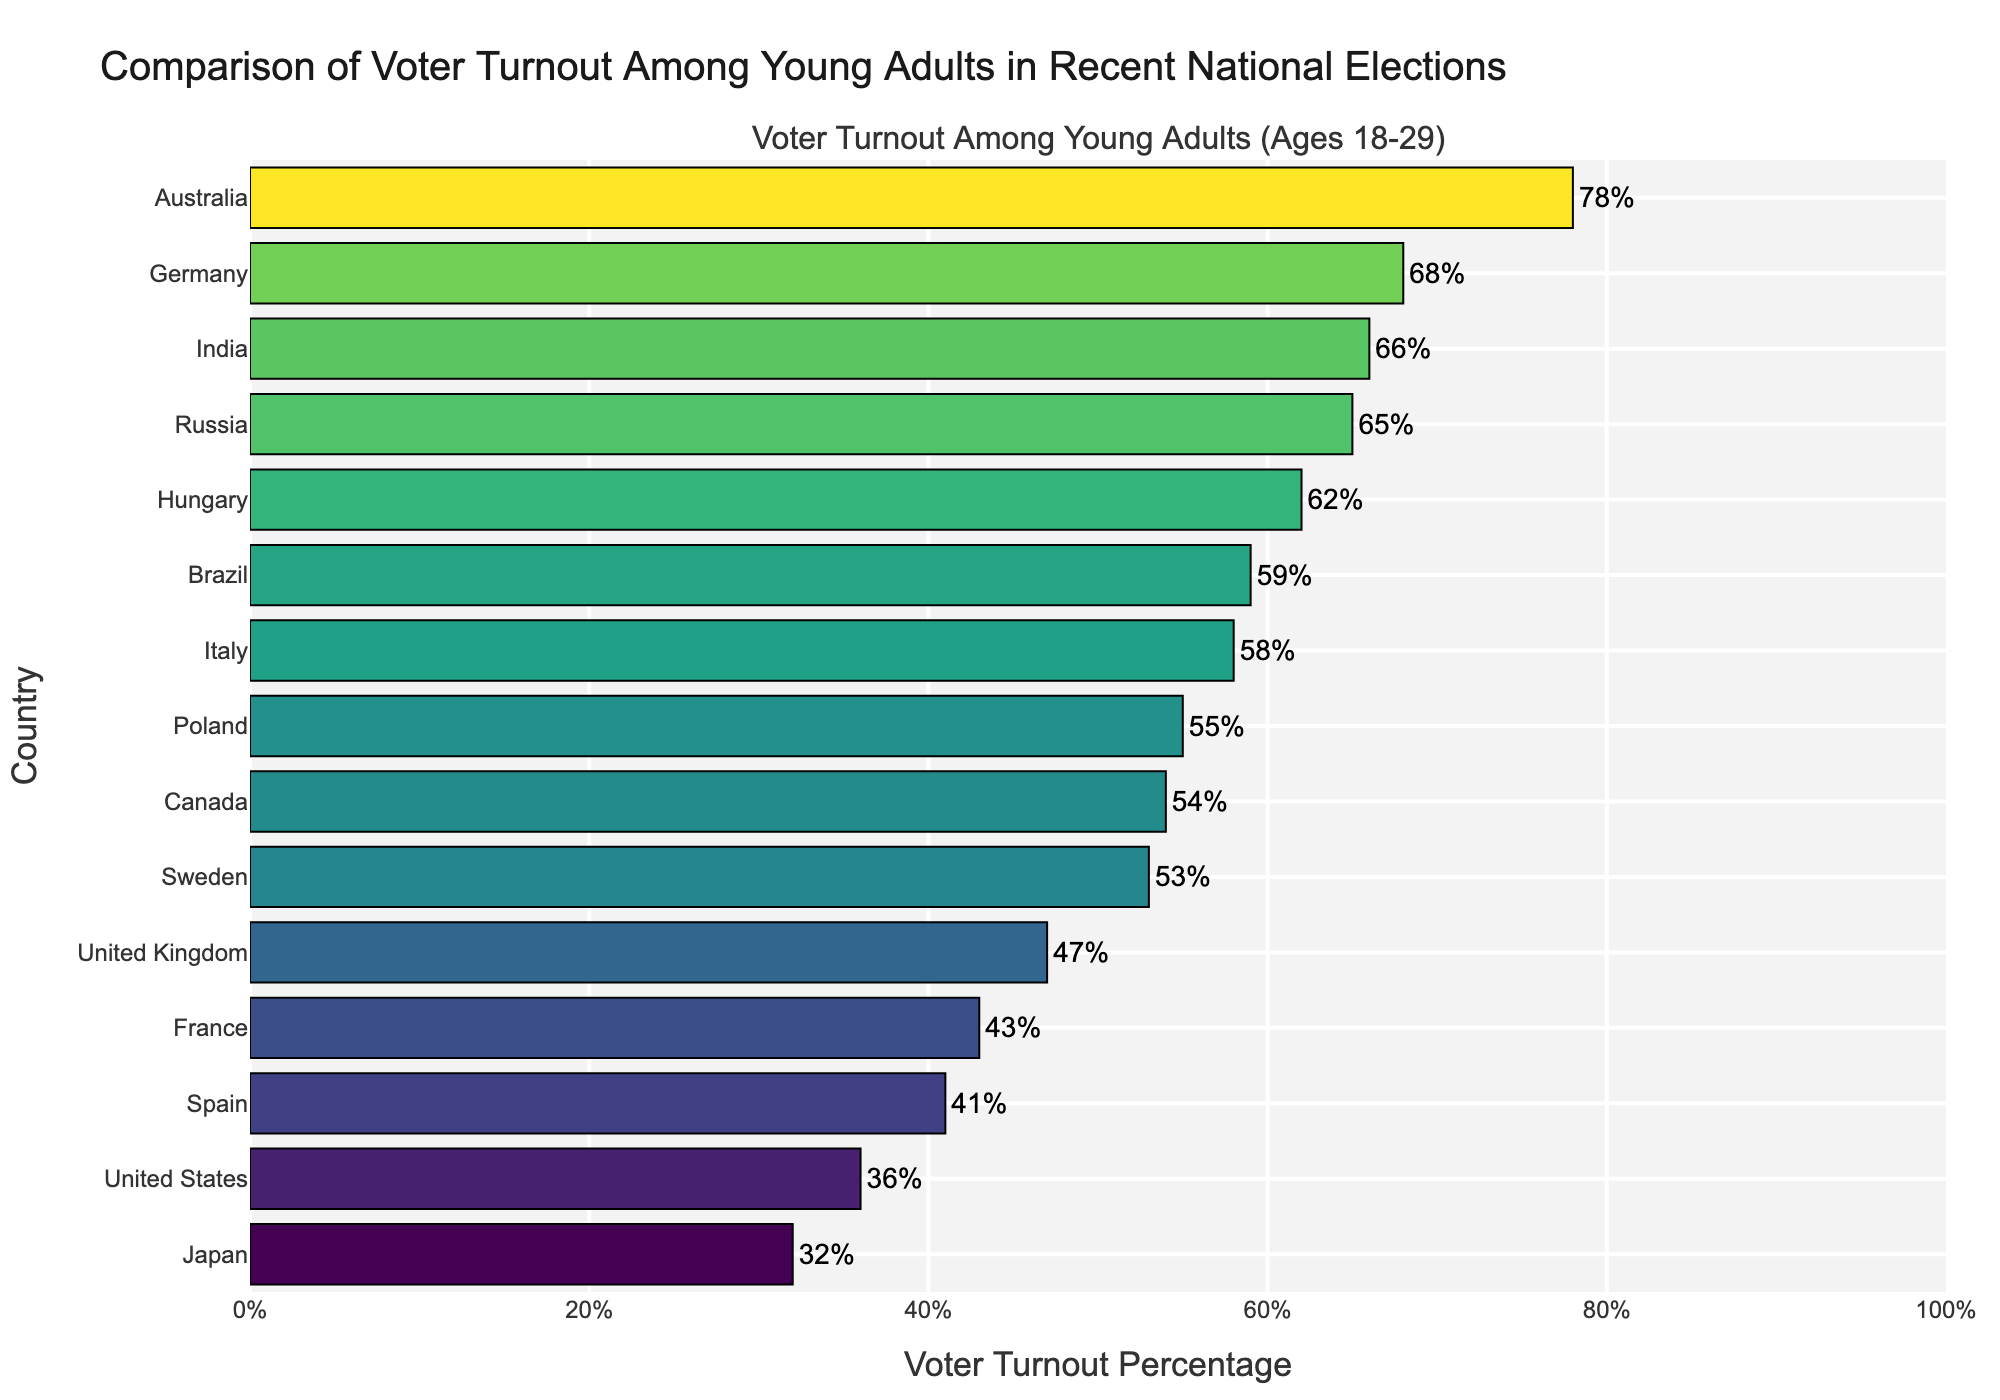Which country has the lowest voter turnout among young adults? The bar chart shows the countries sorted by voter turnout percentage, with the lowest at the top. According to the chart, Japan has the lowest turnout at 32%.
Answer: Japan Which country has the highest voter turnout among young adults? The bar chart is sorted with the highest voter turnout percentage at the bottom. According to the chart, Australia has the highest turnout at 78%.
Answer: Australia How does the voter turnout in the United States compare to that in Japan? In the chart, the bar for the United States is at 36%, whereas Japan is at 32%. Therefore, the United States has a higher turnout than Japan by 4%.
Answer: The United States has a 4% higher turnout What is the combined voter turnout percentage for France, the United Kingdom, and Germany? According to the chart, France has 43%, the United Kingdom has 47%, and Germany has 68%. The combined turnout is 43 + 47 + 68 = 158%.
Answer: 158% How much lower is the voter turnout in Spain compared to Italy? The chart shows Spain has a turnout of 41% and Italy has 58%. The difference is 58% - 41% = 17%.
Answer: 17% lower What is the average voter turnout percentage among Canada, Poland, and Sweden? According to the chart, Canada has 54%, Poland has 55%, and Sweden has 53%. The average turnout is (54 + 55 + 53) / 3 = 54%.
Answer: 54% Which countries have a voter turnout percentage above 60%? The chart highlights the voter turnout percentages, showing countries with turnout above 60% are Hungary (62%), Russia (65%), Brazil (59%), and Australia (78%).
Answer: Hungary, Russia, Australia, and Brazil In terms of voter turnout, how does Sweden rank compared to Poland? From the chart, Poland has a turnout of 55% and Sweden has 53%. Since Poland’s turnout is higher, it ranks above Sweden.
Answer: Poland ranks higher than Sweden What is the median voter turnout percentage among the listed countries? When arranging the turnout percentages in ascending order (32, 36, 41, 43, 47, 53, 54, 55, 58, 59, 62, 65, 66, 68, 78), the median value (middle value) is the 8th value in this sorted list. The median is 55%.
Answer: 55% How much higher is the voter turnout in India compared to Japan? The chart shows that India has a turnout of 66%, while Japan has 32%. The difference is 66% - 32% = 34%.
Answer: 34% higher 